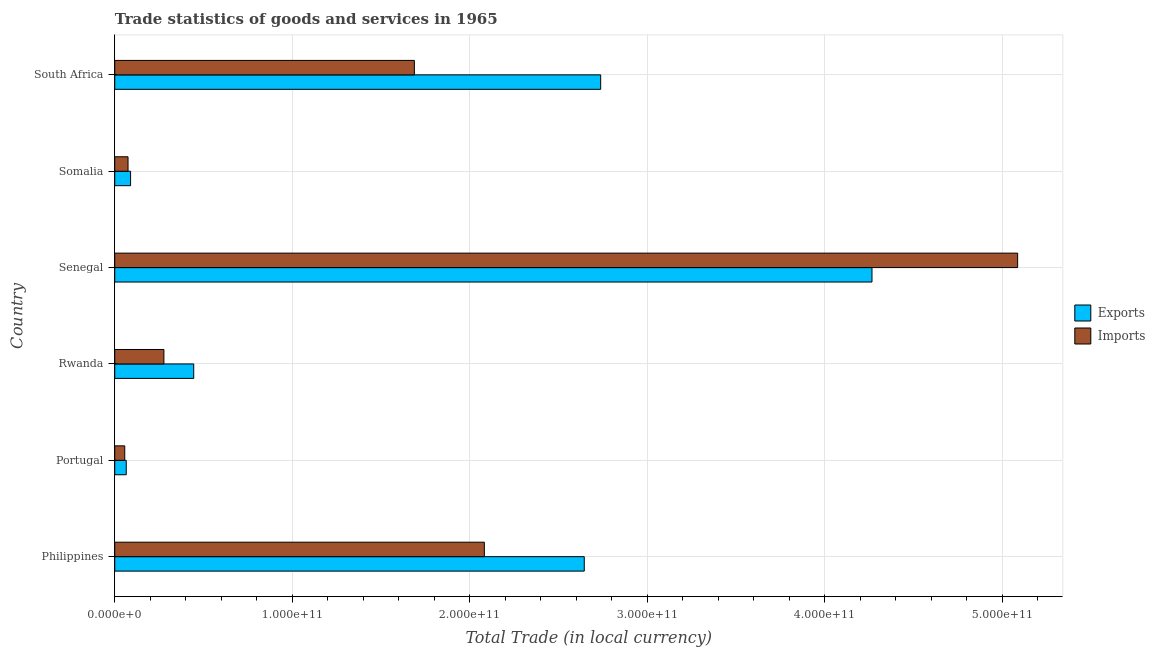How many different coloured bars are there?
Make the answer very short. 2. How many groups of bars are there?
Offer a very short reply. 6. Are the number of bars per tick equal to the number of legend labels?
Your answer should be very brief. Yes. Are the number of bars on each tick of the Y-axis equal?
Offer a very short reply. Yes. How many bars are there on the 2nd tick from the top?
Provide a succinct answer. 2. What is the label of the 4th group of bars from the top?
Your answer should be very brief. Rwanda. What is the imports of goods and services in Senegal?
Offer a very short reply. 5.09e+11. Across all countries, what is the maximum export of goods and services?
Provide a short and direct response. 4.27e+11. Across all countries, what is the minimum imports of goods and services?
Give a very brief answer. 5.64e+09. In which country was the imports of goods and services maximum?
Make the answer very short. Senegal. In which country was the export of goods and services minimum?
Keep it short and to the point. Portugal. What is the total imports of goods and services in the graph?
Offer a very short reply. 9.27e+11. What is the difference between the export of goods and services in Rwanda and that in Somalia?
Give a very brief answer. 3.56e+1. What is the difference between the imports of goods and services in South Africa and the export of goods and services in Senegal?
Give a very brief answer. -2.58e+11. What is the average imports of goods and services per country?
Keep it short and to the point. 1.54e+11. What is the difference between the export of goods and services and imports of goods and services in Philippines?
Provide a short and direct response. 5.63e+1. What is the ratio of the export of goods and services in Rwanda to that in Somalia?
Ensure brevity in your answer.  4.99. What is the difference between the highest and the second highest export of goods and services?
Keep it short and to the point. 1.53e+11. What is the difference between the highest and the lowest imports of goods and services?
Ensure brevity in your answer.  5.03e+11. In how many countries, is the export of goods and services greater than the average export of goods and services taken over all countries?
Ensure brevity in your answer.  3. Is the sum of the export of goods and services in Philippines and Senegal greater than the maximum imports of goods and services across all countries?
Your answer should be very brief. Yes. What does the 1st bar from the top in South Africa represents?
Ensure brevity in your answer.  Imports. What does the 2nd bar from the bottom in Portugal represents?
Your response must be concise. Imports. How many bars are there?
Your answer should be compact. 12. Are all the bars in the graph horizontal?
Give a very brief answer. Yes. How many countries are there in the graph?
Provide a succinct answer. 6. What is the difference between two consecutive major ticks on the X-axis?
Provide a short and direct response. 1.00e+11. Does the graph contain any zero values?
Offer a very short reply. No. Where does the legend appear in the graph?
Your answer should be compact. Center right. How are the legend labels stacked?
Your response must be concise. Vertical. What is the title of the graph?
Ensure brevity in your answer.  Trade statistics of goods and services in 1965. What is the label or title of the X-axis?
Provide a short and direct response. Total Trade (in local currency). What is the Total Trade (in local currency) of Exports in Philippines?
Give a very brief answer. 2.65e+11. What is the Total Trade (in local currency) of Imports in Philippines?
Offer a very short reply. 2.08e+11. What is the Total Trade (in local currency) of Exports in Portugal?
Keep it short and to the point. 6.48e+09. What is the Total Trade (in local currency) in Imports in Portugal?
Your response must be concise. 5.64e+09. What is the Total Trade (in local currency) of Exports in Rwanda?
Your answer should be compact. 4.45e+1. What is the Total Trade (in local currency) in Imports in Rwanda?
Give a very brief answer. 2.77e+1. What is the Total Trade (in local currency) of Exports in Senegal?
Keep it short and to the point. 4.27e+11. What is the Total Trade (in local currency) in Imports in Senegal?
Your answer should be very brief. 5.09e+11. What is the Total Trade (in local currency) in Exports in Somalia?
Ensure brevity in your answer.  8.91e+09. What is the Total Trade (in local currency) in Imports in Somalia?
Your response must be concise. 7.49e+09. What is the Total Trade (in local currency) in Exports in South Africa?
Keep it short and to the point. 2.74e+11. What is the Total Trade (in local currency) in Imports in South Africa?
Ensure brevity in your answer.  1.69e+11. Across all countries, what is the maximum Total Trade (in local currency) of Exports?
Make the answer very short. 4.27e+11. Across all countries, what is the maximum Total Trade (in local currency) in Imports?
Keep it short and to the point. 5.09e+11. Across all countries, what is the minimum Total Trade (in local currency) of Exports?
Your answer should be very brief. 6.48e+09. Across all countries, what is the minimum Total Trade (in local currency) of Imports?
Your response must be concise. 5.64e+09. What is the total Total Trade (in local currency) of Exports in the graph?
Provide a succinct answer. 1.02e+12. What is the total Total Trade (in local currency) in Imports in the graph?
Offer a terse response. 9.27e+11. What is the difference between the Total Trade (in local currency) of Exports in Philippines and that in Portugal?
Offer a terse response. 2.58e+11. What is the difference between the Total Trade (in local currency) of Imports in Philippines and that in Portugal?
Make the answer very short. 2.03e+11. What is the difference between the Total Trade (in local currency) of Exports in Philippines and that in Rwanda?
Your answer should be compact. 2.20e+11. What is the difference between the Total Trade (in local currency) of Imports in Philippines and that in Rwanda?
Your answer should be compact. 1.81e+11. What is the difference between the Total Trade (in local currency) in Exports in Philippines and that in Senegal?
Your answer should be compact. -1.62e+11. What is the difference between the Total Trade (in local currency) in Imports in Philippines and that in Senegal?
Make the answer very short. -3.01e+11. What is the difference between the Total Trade (in local currency) of Exports in Philippines and that in Somalia?
Your response must be concise. 2.56e+11. What is the difference between the Total Trade (in local currency) in Imports in Philippines and that in Somalia?
Your answer should be compact. 2.01e+11. What is the difference between the Total Trade (in local currency) in Exports in Philippines and that in South Africa?
Keep it short and to the point. -9.25e+09. What is the difference between the Total Trade (in local currency) of Imports in Philippines and that in South Africa?
Provide a short and direct response. 3.94e+1. What is the difference between the Total Trade (in local currency) in Exports in Portugal and that in Rwanda?
Offer a terse response. -3.80e+1. What is the difference between the Total Trade (in local currency) of Imports in Portugal and that in Rwanda?
Your response must be concise. -2.21e+1. What is the difference between the Total Trade (in local currency) in Exports in Portugal and that in Senegal?
Ensure brevity in your answer.  -4.20e+11. What is the difference between the Total Trade (in local currency) in Imports in Portugal and that in Senegal?
Keep it short and to the point. -5.03e+11. What is the difference between the Total Trade (in local currency) in Exports in Portugal and that in Somalia?
Offer a very short reply. -2.43e+09. What is the difference between the Total Trade (in local currency) in Imports in Portugal and that in Somalia?
Give a very brief answer. -1.85e+09. What is the difference between the Total Trade (in local currency) of Exports in Portugal and that in South Africa?
Your answer should be very brief. -2.67e+11. What is the difference between the Total Trade (in local currency) in Imports in Portugal and that in South Africa?
Your answer should be compact. -1.63e+11. What is the difference between the Total Trade (in local currency) of Exports in Rwanda and that in Senegal?
Offer a terse response. -3.82e+11. What is the difference between the Total Trade (in local currency) of Imports in Rwanda and that in Senegal?
Offer a very short reply. -4.81e+11. What is the difference between the Total Trade (in local currency) in Exports in Rwanda and that in Somalia?
Offer a terse response. 3.56e+1. What is the difference between the Total Trade (in local currency) in Imports in Rwanda and that in Somalia?
Give a very brief answer. 2.02e+1. What is the difference between the Total Trade (in local currency) of Exports in Rwanda and that in South Africa?
Ensure brevity in your answer.  -2.29e+11. What is the difference between the Total Trade (in local currency) of Imports in Rwanda and that in South Africa?
Provide a succinct answer. -1.41e+11. What is the difference between the Total Trade (in local currency) in Exports in Senegal and that in Somalia?
Keep it short and to the point. 4.18e+11. What is the difference between the Total Trade (in local currency) of Imports in Senegal and that in Somalia?
Keep it short and to the point. 5.01e+11. What is the difference between the Total Trade (in local currency) of Exports in Senegal and that in South Africa?
Provide a succinct answer. 1.53e+11. What is the difference between the Total Trade (in local currency) of Imports in Senegal and that in South Africa?
Make the answer very short. 3.40e+11. What is the difference between the Total Trade (in local currency) in Exports in Somalia and that in South Africa?
Provide a succinct answer. -2.65e+11. What is the difference between the Total Trade (in local currency) in Imports in Somalia and that in South Africa?
Provide a short and direct response. -1.61e+11. What is the difference between the Total Trade (in local currency) of Exports in Philippines and the Total Trade (in local currency) of Imports in Portugal?
Ensure brevity in your answer.  2.59e+11. What is the difference between the Total Trade (in local currency) of Exports in Philippines and the Total Trade (in local currency) of Imports in Rwanda?
Offer a terse response. 2.37e+11. What is the difference between the Total Trade (in local currency) of Exports in Philippines and the Total Trade (in local currency) of Imports in Senegal?
Ensure brevity in your answer.  -2.44e+11. What is the difference between the Total Trade (in local currency) in Exports in Philippines and the Total Trade (in local currency) in Imports in Somalia?
Provide a succinct answer. 2.57e+11. What is the difference between the Total Trade (in local currency) of Exports in Philippines and the Total Trade (in local currency) of Imports in South Africa?
Offer a very short reply. 9.57e+1. What is the difference between the Total Trade (in local currency) in Exports in Portugal and the Total Trade (in local currency) in Imports in Rwanda?
Provide a short and direct response. -2.12e+1. What is the difference between the Total Trade (in local currency) of Exports in Portugal and the Total Trade (in local currency) of Imports in Senegal?
Your answer should be very brief. -5.02e+11. What is the difference between the Total Trade (in local currency) of Exports in Portugal and the Total Trade (in local currency) of Imports in Somalia?
Offer a very short reply. -1.01e+09. What is the difference between the Total Trade (in local currency) in Exports in Portugal and the Total Trade (in local currency) in Imports in South Africa?
Provide a succinct answer. -1.62e+11. What is the difference between the Total Trade (in local currency) in Exports in Rwanda and the Total Trade (in local currency) in Imports in Senegal?
Offer a very short reply. -4.64e+11. What is the difference between the Total Trade (in local currency) in Exports in Rwanda and the Total Trade (in local currency) in Imports in Somalia?
Your response must be concise. 3.70e+1. What is the difference between the Total Trade (in local currency) in Exports in Rwanda and the Total Trade (in local currency) in Imports in South Africa?
Your response must be concise. -1.24e+11. What is the difference between the Total Trade (in local currency) of Exports in Senegal and the Total Trade (in local currency) of Imports in Somalia?
Offer a terse response. 4.19e+11. What is the difference between the Total Trade (in local currency) of Exports in Senegal and the Total Trade (in local currency) of Imports in South Africa?
Your response must be concise. 2.58e+11. What is the difference between the Total Trade (in local currency) in Exports in Somalia and the Total Trade (in local currency) in Imports in South Africa?
Ensure brevity in your answer.  -1.60e+11. What is the average Total Trade (in local currency) in Exports per country?
Offer a terse response. 1.71e+11. What is the average Total Trade (in local currency) of Imports per country?
Make the answer very short. 1.54e+11. What is the difference between the Total Trade (in local currency) in Exports and Total Trade (in local currency) in Imports in Philippines?
Offer a very short reply. 5.63e+1. What is the difference between the Total Trade (in local currency) in Exports and Total Trade (in local currency) in Imports in Portugal?
Ensure brevity in your answer.  8.44e+08. What is the difference between the Total Trade (in local currency) of Exports and Total Trade (in local currency) of Imports in Rwanda?
Your answer should be very brief. 1.68e+1. What is the difference between the Total Trade (in local currency) in Exports and Total Trade (in local currency) in Imports in Senegal?
Offer a very short reply. -8.21e+1. What is the difference between the Total Trade (in local currency) of Exports and Total Trade (in local currency) of Imports in Somalia?
Provide a succinct answer. 1.43e+09. What is the difference between the Total Trade (in local currency) in Exports and Total Trade (in local currency) in Imports in South Africa?
Provide a short and direct response. 1.05e+11. What is the ratio of the Total Trade (in local currency) of Exports in Philippines to that in Portugal?
Give a very brief answer. 40.83. What is the ratio of the Total Trade (in local currency) of Imports in Philippines to that in Portugal?
Ensure brevity in your answer.  36.96. What is the ratio of the Total Trade (in local currency) of Exports in Philippines to that in Rwanda?
Make the answer very short. 5.95. What is the ratio of the Total Trade (in local currency) of Imports in Philippines to that in Rwanda?
Offer a very short reply. 7.52. What is the ratio of the Total Trade (in local currency) in Exports in Philippines to that in Senegal?
Your response must be concise. 0.62. What is the ratio of the Total Trade (in local currency) in Imports in Philippines to that in Senegal?
Provide a short and direct response. 0.41. What is the ratio of the Total Trade (in local currency) of Exports in Philippines to that in Somalia?
Your response must be concise. 29.68. What is the ratio of the Total Trade (in local currency) of Imports in Philippines to that in Somalia?
Give a very brief answer. 27.82. What is the ratio of the Total Trade (in local currency) of Exports in Philippines to that in South Africa?
Your answer should be very brief. 0.97. What is the ratio of the Total Trade (in local currency) of Imports in Philippines to that in South Africa?
Make the answer very short. 1.23. What is the ratio of the Total Trade (in local currency) of Exports in Portugal to that in Rwanda?
Ensure brevity in your answer.  0.15. What is the ratio of the Total Trade (in local currency) in Imports in Portugal to that in Rwanda?
Provide a succinct answer. 0.2. What is the ratio of the Total Trade (in local currency) in Exports in Portugal to that in Senegal?
Give a very brief answer. 0.02. What is the ratio of the Total Trade (in local currency) of Imports in Portugal to that in Senegal?
Your answer should be compact. 0.01. What is the ratio of the Total Trade (in local currency) in Exports in Portugal to that in Somalia?
Keep it short and to the point. 0.73. What is the ratio of the Total Trade (in local currency) of Imports in Portugal to that in Somalia?
Offer a terse response. 0.75. What is the ratio of the Total Trade (in local currency) in Exports in Portugal to that in South Africa?
Offer a very short reply. 0.02. What is the ratio of the Total Trade (in local currency) in Imports in Portugal to that in South Africa?
Your answer should be compact. 0.03. What is the ratio of the Total Trade (in local currency) of Exports in Rwanda to that in Senegal?
Ensure brevity in your answer.  0.1. What is the ratio of the Total Trade (in local currency) in Imports in Rwanda to that in Senegal?
Make the answer very short. 0.05. What is the ratio of the Total Trade (in local currency) of Exports in Rwanda to that in Somalia?
Provide a short and direct response. 4.99. What is the ratio of the Total Trade (in local currency) of Imports in Rwanda to that in Somalia?
Offer a very short reply. 3.7. What is the ratio of the Total Trade (in local currency) of Exports in Rwanda to that in South Africa?
Provide a succinct answer. 0.16. What is the ratio of the Total Trade (in local currency) in Imports in Rwanda to that in South Africa?
Keep it short and to the point. 0.16. What is the ratio of the Total Trade (in local currency) of Exports in Senegal to that in Somalia?
Provide a short and direct response. 47.87. What is the ratio of the Total Trade (in local currency) in Imports in Senegal to that in Somalia?
Keep it short and to the point. 67.97. What is the ratio of the Total Trade (in local currency) in Exports in Senegal to that in South Africa?
Make the answer very short. 1.56. What is the ratio of the Total Trade (in local currency) of Imports in Senegal to that in South Africa?
Give a very brief answer. 3.01. What is the ratio of the Total Trade (in local currency) in Exports in Somalia to that in South Africa?
Offer a terse response. 0.03. What is the ratio of the Total Trade (in local currency) in Imports in Somalia to that in South Africa?
Your answer should be very brief. 0.04. What is the difference between the highest and the second highest Total Trade (in local currency) in Exports?
Offer a very short reply. 1.53e+11. What is the difference between the highest and the second highest Total Trade (in local currency) of Imports?
Your answer should be very brief. 3.01e+11. What is the difference between the highest and the lowest Total Trade (in local currency) in Exports?
Keep it short and to the point. 4.20e+11. What is the difference between the highest and the lowest Total Trade (in local currency) in Imports?
Provide a short and direct response. 5.03e+11. 